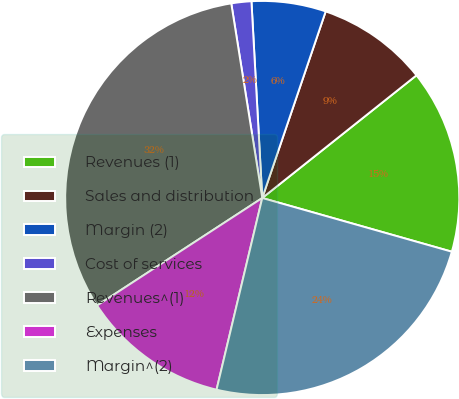Convert chart. <chart><loc_0><loc_0><loc_500><loc_500><pie_chart><fcel>Revenues (1)<fcel>Sales and distribution<fcel>Margin (2)<fcel>Cost of services<fcel>Revenues^(1)<fcel>Expenses<fcel>Margin^(2)<nl><fcel>15.09%<fcel>9.09%<fcel>6.09%<fcel>1.64%<fcel>31.67%<fcel>12.09%<fcel>24.33%<nl></chart> 